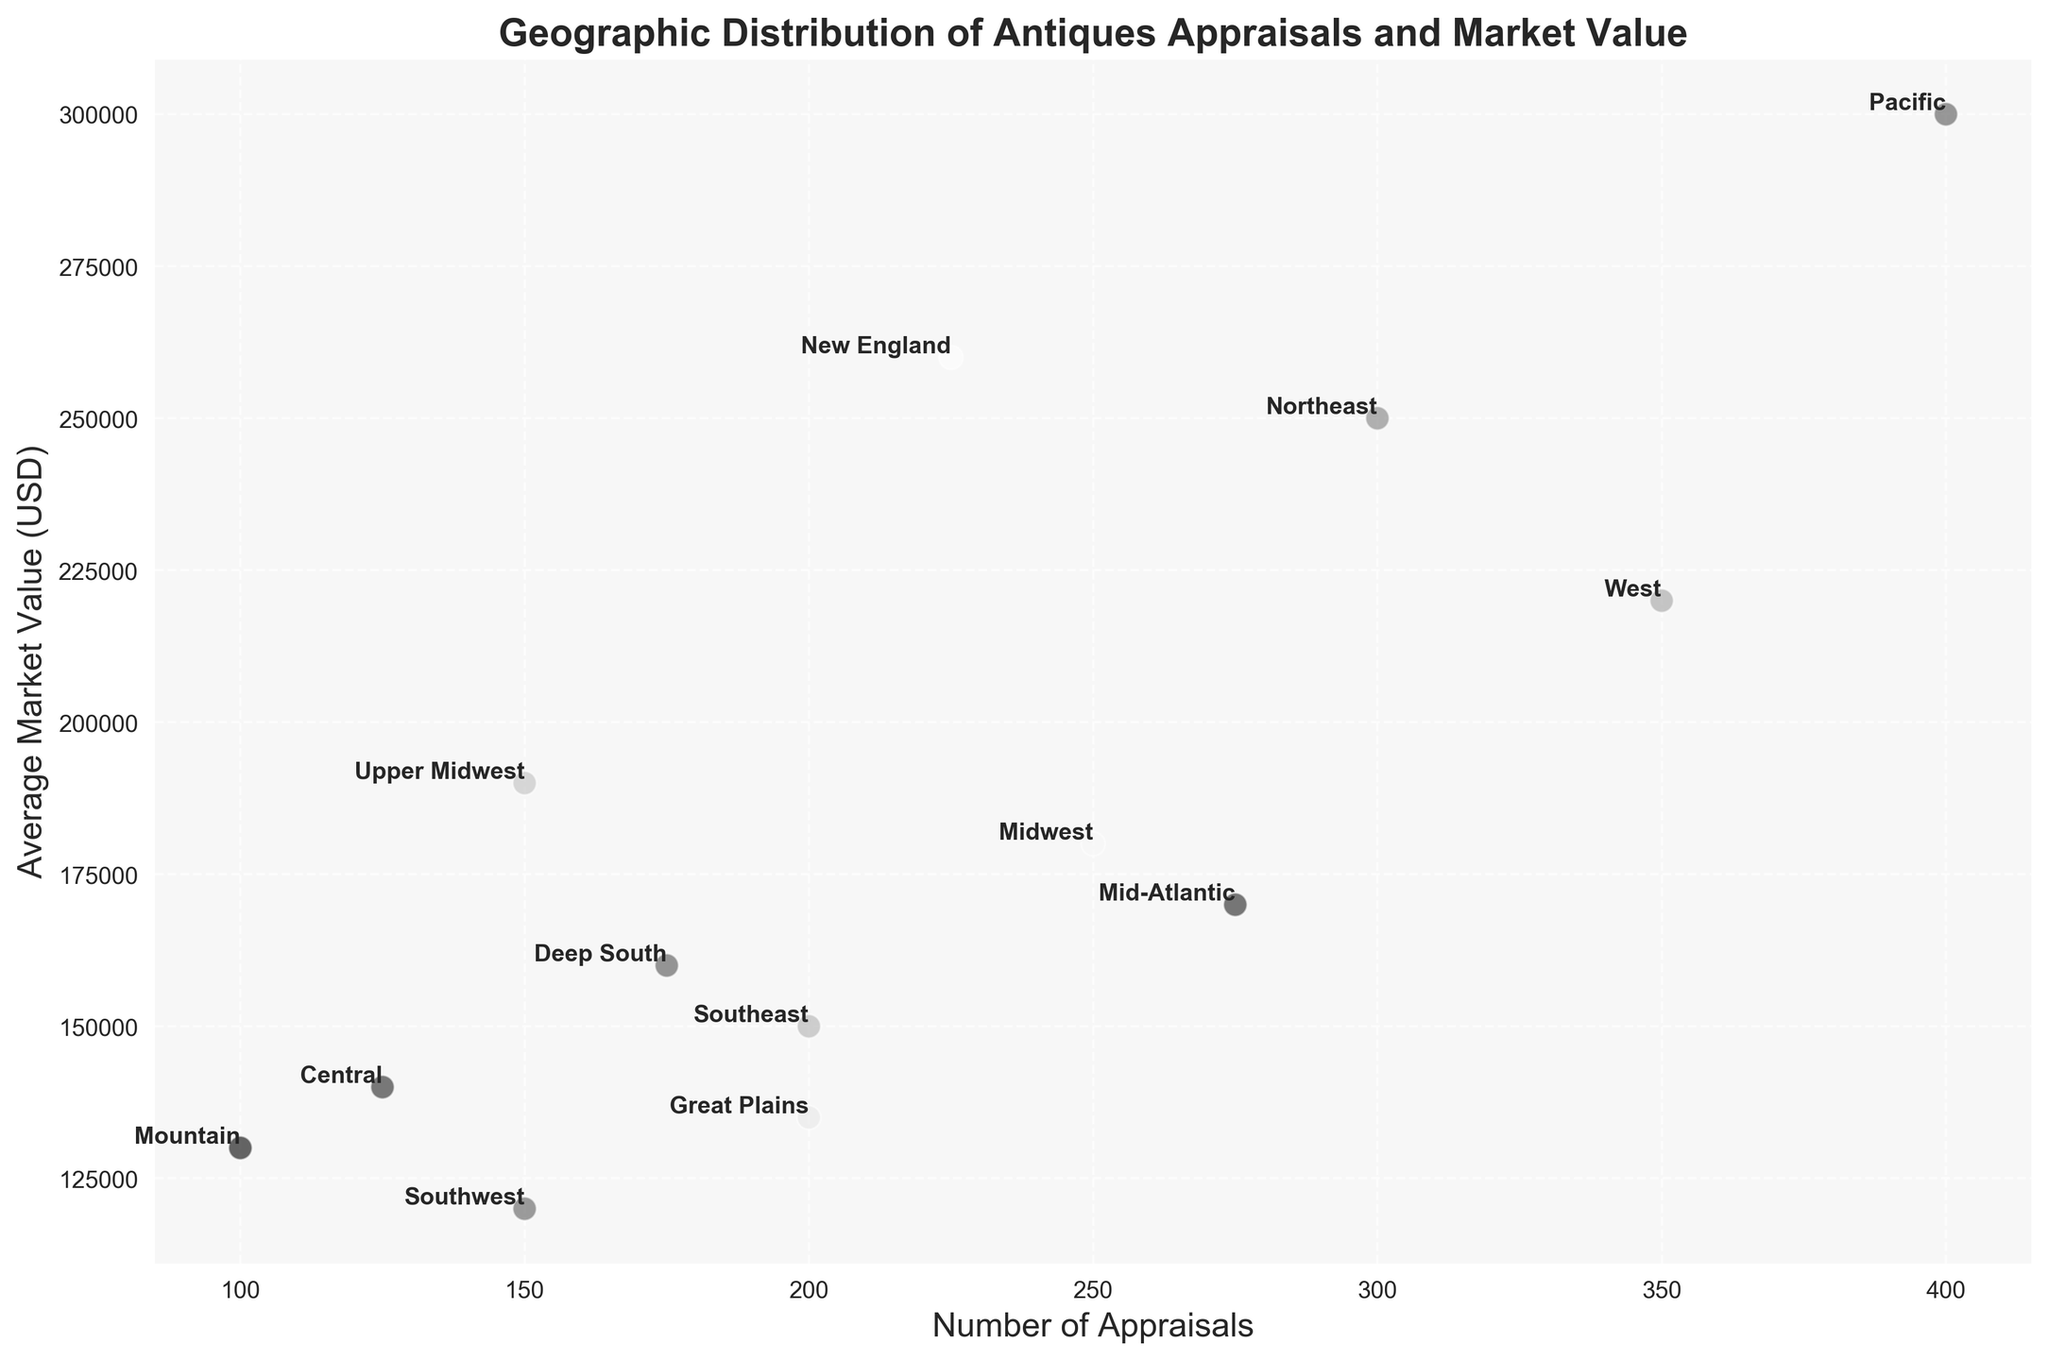What region has the highest number of appraisals, and what is its average market value? Find the region with the highest number on the x-axis and read its corresponding y-axis value. The highest is at 400 appraisals; this corresponds to the Pacific region with an average market value of $300,000.
Answer: Pacific, $300,000 Which region has the lowest average market value, and how many appraisals does it have? Find the region with the lowest value on the y-axis and read its corresponding x-axis value. The lowest is $120,000; this corresponds to the Southwest region with 150 appraisals.
Answer: Southwest, 150 What is the average number of appraisals for the regions with market values above $200,000? Identify the regions above $200,000: Northeast, West, Pacific, and New England. The number of appraisals are 300, 350, 400, and 225 respectively. Calculate the average: (300 + 350 + 400 + 225) / 4 = 1275 / 4 = 318.75.
Answer: 318.75 Which region has a higher average market value: Midwest or Deep South? Compare the y-axis values of the regions Midwest ($180,000) and Deep South ($160,000). The Midwest is higher.
Answer: Midwest Which region has fewer appraisals but a higher average market value compared to the Central region? Central has 125 appraisals and $140,000 market value. Regions with fewer appraisals are Mountain (100) and Great Plains (200). Only Mountain has a higher market value ($130,000 to $140,000). Verify visually.
Answer: Mountain Which region is nearest on the plot to the Great Plains in terms of both appraisals and market value? Look for the point closest to Great Plains (200 appraisals and $135,000). Deep South has 175 appraisals and $160,000 market value, visually near to Great Plains.
Answer: Deep South Calculate the total number of appraisals for regions with average market values below $150,000. Identify regions: Southeast, Southwest, Mountain, Central, and Great Plains. Appraisals are 200, 150, 100, 125, and 200 respectively. Sum: 200 + 150 + 100 + 125 + 200 = 775.
Answer: 775 Which region appears to be an outlier in terms of appraisals or market value? Identify points that are visibly distinct. The Pacific region is an outlier with the highest appraisals (400) and highest market value ($300,000).
Answer: Pacific 